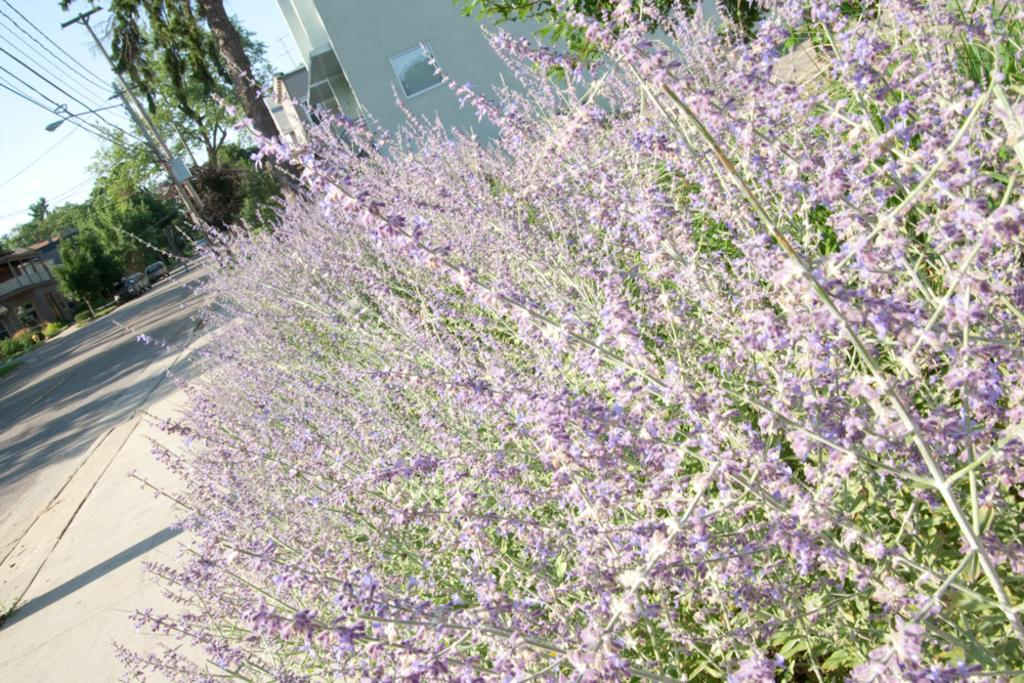What type of flowers can be seen in the image? There are purple color flowers in the image. What structures are present in the image? There are buildings, light poles, and current poles in the image. What type of vegetation is visible in the image? There are trees in the image. What utility infrastructure is present in the image? There are wires in the image. What type of transportation is visible in the image? There are vehicles on the road in the image. What is the color of the sky in the image? The sky is blue in the image. Is there a veil covering the flowers in the image? No, there is no veil present in the image; the flowers are visible. What type of chain is holding the vehicles together in the image? There is no chain holding the vehicles together in the image; they are separate and on the road. 